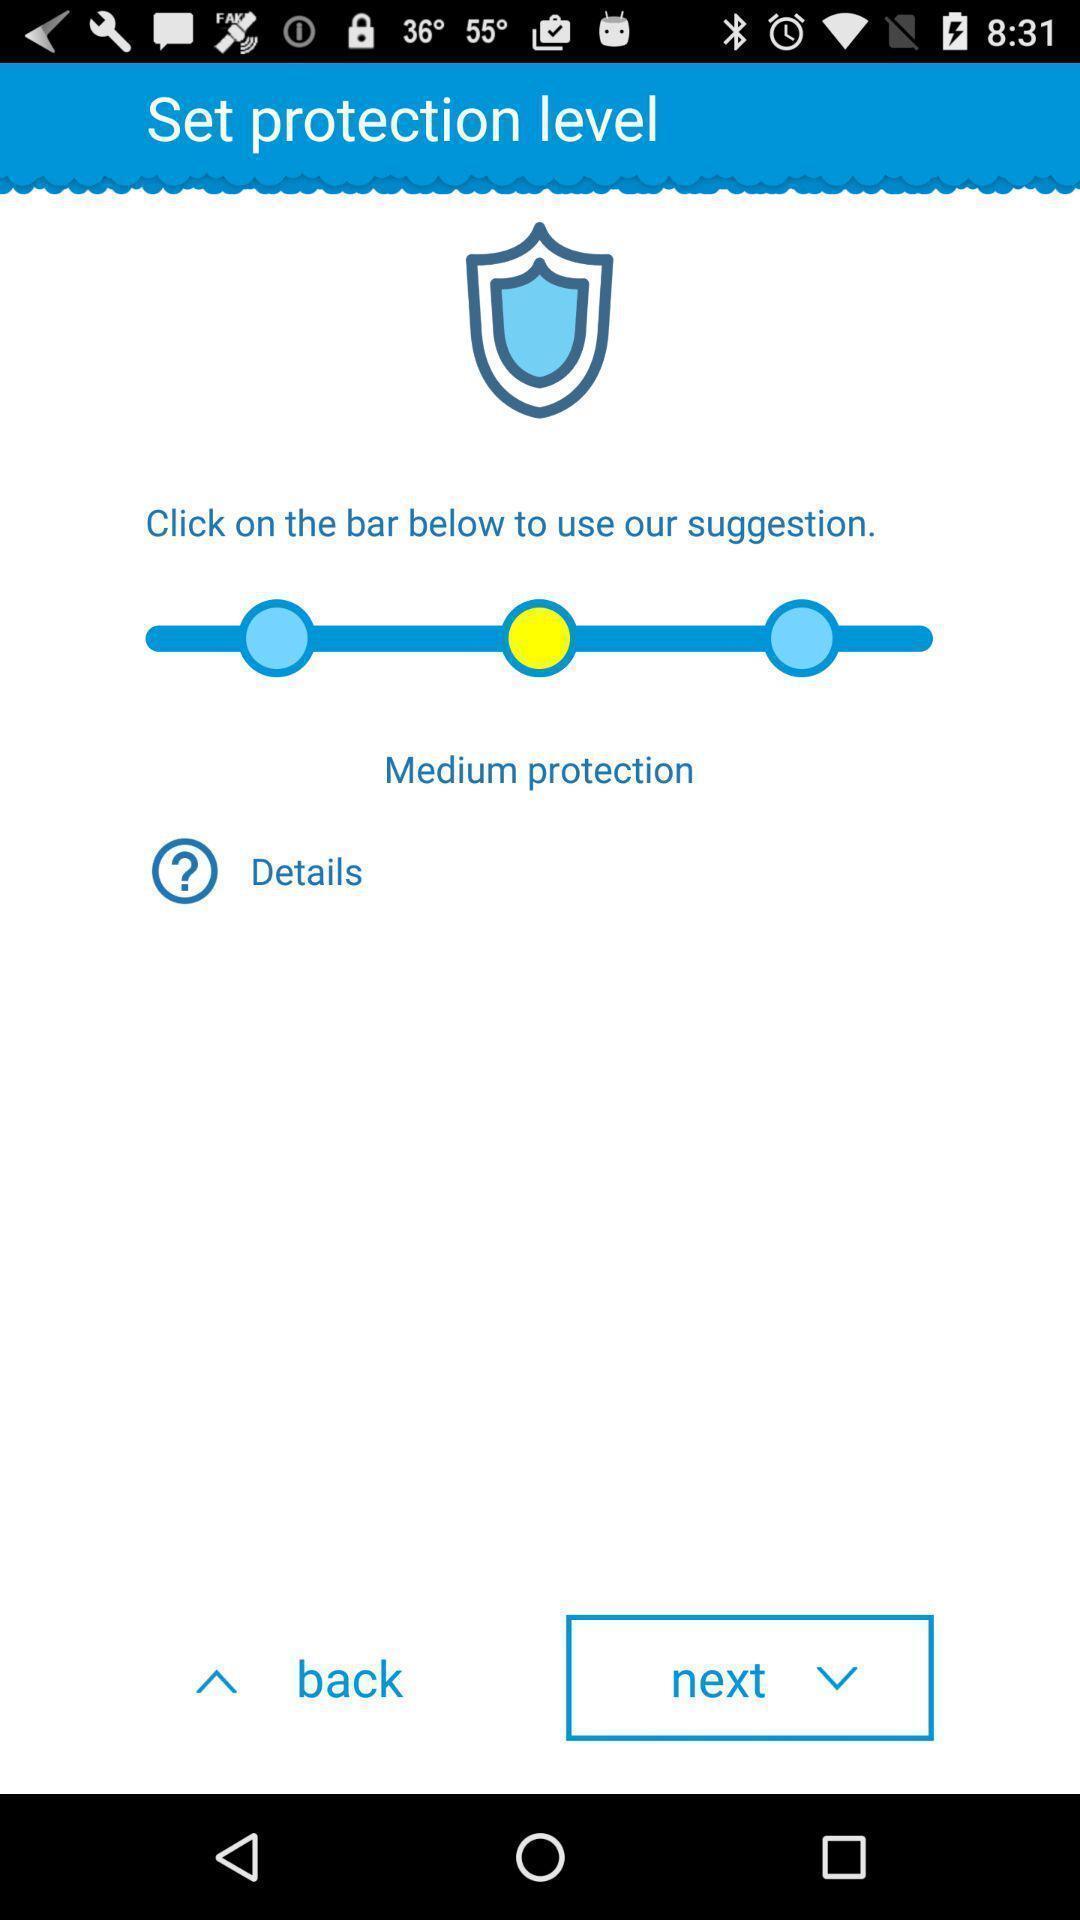What can you discern from this picture? Social app for setting protection level. 